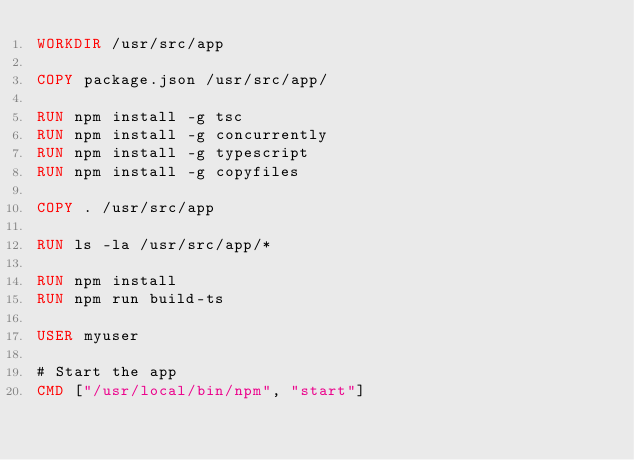Convert code to text. <code><loc_0><loc_0><loc_500><loc_500><_Dockerfile_>WORKDIR /usr/src/app

COPY package.json /usr/src/app/

RUN npm install -g tsc 
RUN npm install -g concurrently 
RUN npm install -g typescript
RUN npm install -g copyfiles

COPY . /usr/src/app

RUN ls -la /usr/src/app/*

RUN npm install
RUN npm run build-ts

USER myuser

# Start the app
CMD ["/usr/local/bin/npm", "start"]</code> 